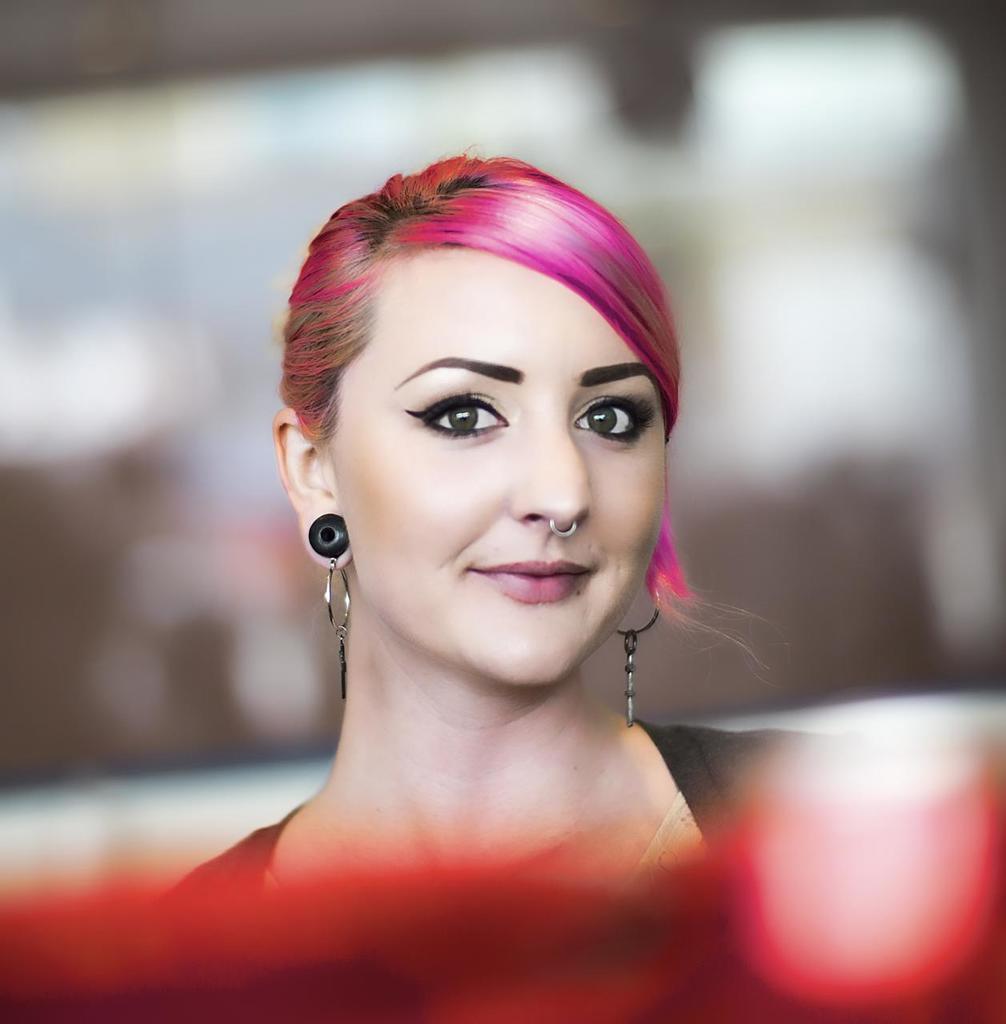Please provide a concise description of this image. In this image I can see a woman is smiling, she has pink color hair and black color earrings. 